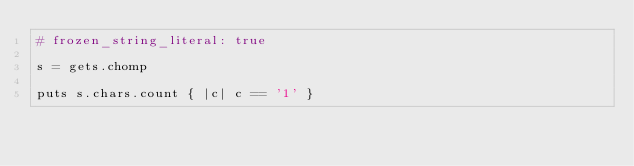Convert code to text. <code><loc_0><loc_0><loc_500><loc_500><_Ruby_># frozen_string_literal: true

s = gets.chomp

puts s.chars.count { |c| c == '1' }</code> 